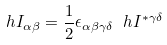<formula> <loc_0><loc_0><loc_500><loc_500>\ h { I } _ { \alpha \beta } = \frac { 1 } { 2 } \epsilon _ { \alpha \beta \gamma \delta } \ h { I } ^ { * \gamma \delta }</formula> 